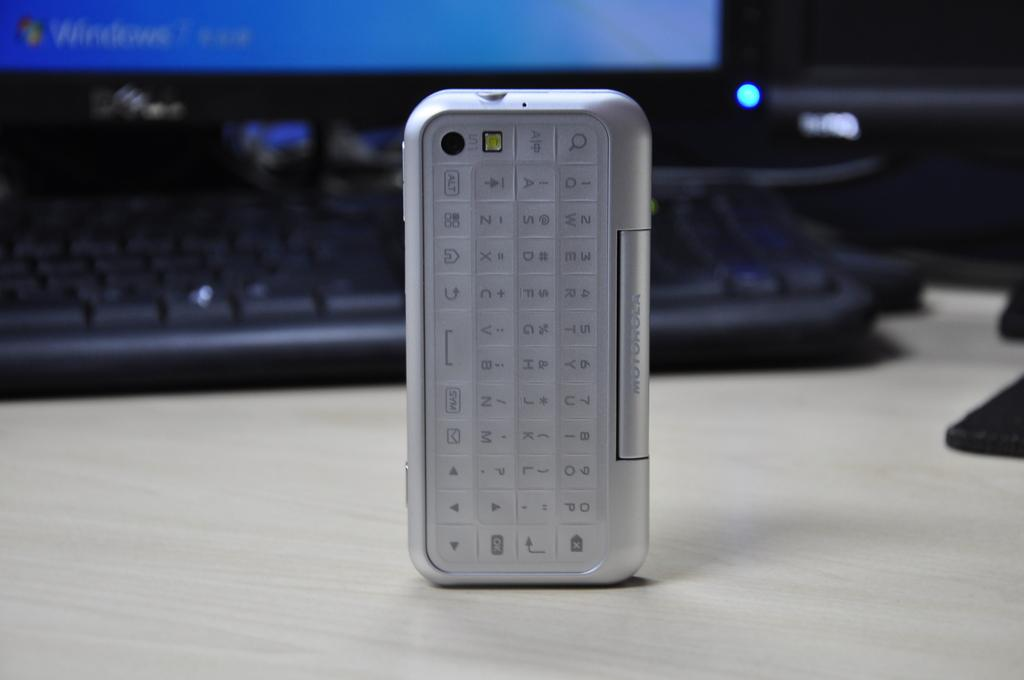What electronic device is visible in the image? There is a mobile phone in the image. What is the purpose of the keyboard in the image? The keyboard is likely used for typing or inputting data. What is the monitor used for in the image? The monitor is likely used for displaying information or visuals. What other objects can be seen on the table in the image? There are other objects on the table, but their specific purpose or identity is not mentioned in the provided facts. What type of lumber is being used to build the impulse in the image? There is no mention of an impulse or lumber in the image; it features electronic devices and a table. 